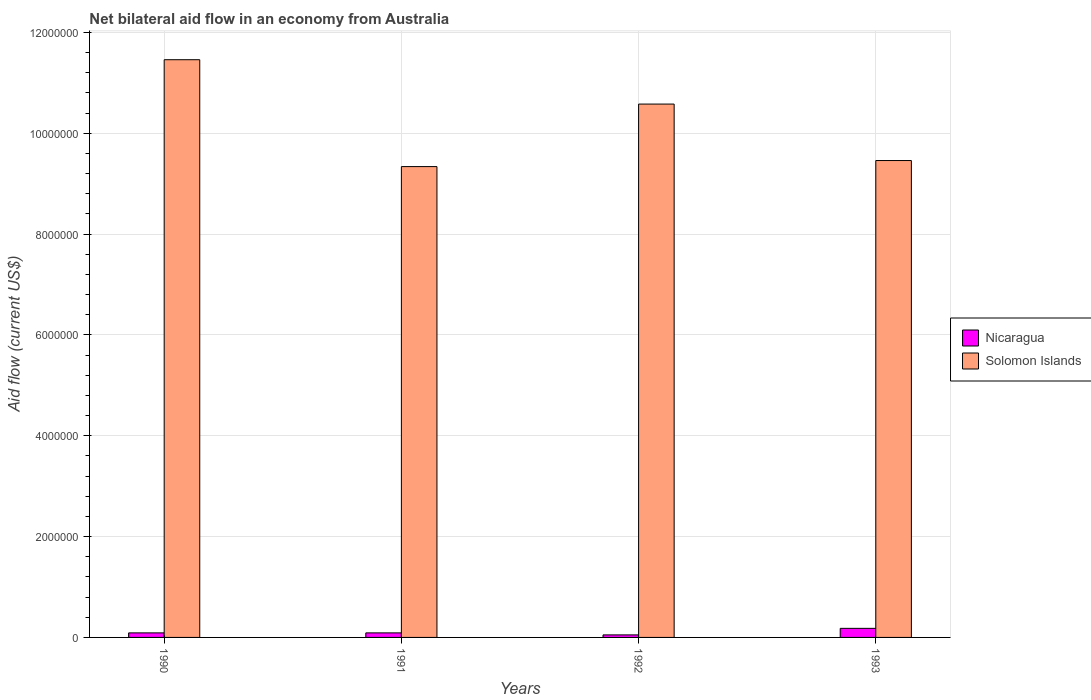How many bars are there on the 4th tick from the left?
Offer a very short reply. 2. What is the net bilateral aid flow in Nicaragua in 1992?
Ensure brevity in your answer.  5.00e+04. Across all years, what is the maximum net bilateral aid flow in Solomon Islands?
Offer a terse response. 1.15e+07. Across all years, what is the minimum net bilateral aid flow in Solomon Islands?
Offer a terse response. 9.34e+06. What is the total net bilateral aid flow in Solomon Islands in the graph?
Make the answer very short. 4.08e+07. What is the difference between the net bilateral aid flow in Solomon Islands in 1990 and that in 1993?
Offer a terse response. 2.00e+06. What is the difference between the net bilateral aid flow in Solomon Islands in 1992 and the net bilateral aid flow in Nicaragua in 1993?
Make the answer very short. 1.04e+07. What is the average net bilateral aid flow in Solomon Islands per year?
Offer a very short reply. 1.02e+07. In the year 1993, what is the difference between the net bilateral aid flow in Nicaragua and net bilateral aid flow in Solomon Islands?
Ensure brevity in your answer.  -9.28e+06. What is the ratio of the net bilateral aid flow in Nicaragua in 1990 to that in 1991?
Provide a short and direct response. 1. What is the difference between the highest and the second highest net bilateral aid flow in Nicaragua?
Offer a terse response. 9.00e+04. What does the 1st bar from the left in 1991 represents?
Give a very brief answer. Nicaragua. What does the 1st bar from the right in 1991 represents?
Give a very brief answer. Solomon Islands. How many bars are there?
Your answer should be very brief. 8. How many years are there in the graph?
Make the answer very short. 4. Does the graph contain any zero values?
Keep it short and to the point. No. Where does the legend appear in the graph?
Provide a succinct answer. Center right. How are the legend labels stacked?
Offer a terse response. Vertical. What is the title of the graph?
Your answer should be very brief. Net bilateral aid flow in an economy from Australia. What is the label or title of the X-axis?
Your response must be concise. Years. What is the Aid flow (current US$) of Solomon Islands in 1990?
Your answer should be very brief. 1.15e+07. What is the Aid flow (current US$) in Solomon Islands in 1991?
Keep it short and to the point. 9.34e+06. What is the Aid flow (current US$) of Nicaragua in 1992?
Your answer should be very brief. 5.00e+04. What is the Aid flow (current US$) of Solomon Islands in 1992?
Keep it short and to the point. 1.06e+07. What is the Aid flow (current US$) in Solomon Islands in 1993?
Provide a succinct answer. 9.46e+06. Across all years, what is the maximum Aid flow (current US$) in Solomon Islands?
Offer a very short reply. 1.15e+07. Across all years, what is the minimum Aid flow (current US$) of Nicaragua?
Keep it short and to the point. 5.00e+04. Across all years, what is the minimum Aid flow (current US$) of Solomon Islands?
Keep it short and to the point. 9.34e+06. What is the total Aid flow (current US$) in Nicaragua in the graph?
Keep it short and to the point. 4.10e+05. What is the total Aid flow (current US$) in Solomon Islands in the graph?
Ensure brevity in your answer.  4.08e+07. What is the difference between the Aid flow (current US$) of Nicaragua in 1990 and that in 1991?
Offer a terse response. 0. What is the difference between the Aid flow (current US$) of Solomon Islands in 1990 and that in 1991?
Provide a succinct answer. 2.12e+06. What is the difference between the Aid flow (current US$) in Solomon Islands in 1990 and that in 1992?
Your response must be concise. 8.80e+05. What is the difference between the Aid flow (current US$) in Solomon Islands in 1991 and that in 1992?
Give a very brief answer. -1.24e+06. What is the difference between the Aid flow (current US$) in Solomon Islands in 1991 and that in 1993?
Provide a short and direct response. -1.20e+05. What is the difference between the Aid flow (current US$) of Nicaragua in 1992 and that in 1993?
Offer a very short reply. -1.30e+05. What is the difference between the Aid flow (current US$) in Solomon Islands in 1992 and that in 1993?
Keep it short and to the point. 1.12e+06. What is the difference between the Aid flow (current US$) in Nicaragua in 1990 and the Aid flow (current US$) in Solomon Islands in 1991?
Your answer should be compact. -9.25e+06. What is the difference between the Aid flow (current US$) in Nicaragua in 1990 and the Aid flow (current US$) in Solomon Islands in 1992?
Give a very brief answer. -1.05e+07. What is the difference between the Aid flow (current US$) of Nicaragua in 1990 and the Aid flow (current US$) of Solomon Islands in 1993?
Ensure brevity in your answer.  -9.37e+06. What is the difference between the Aid flow (current US$) of Nicaragua in 1991 and the Aid flow (current US$) of Solomon Islands in 1992?
Your response must be concise. -1.05e+07. What is the difference between the Aid flow (current US$) in Nicaragua in 1991 and the Aid flow (current US$) in Solomon Islands in 1993?
Ensure brevity in your answer.  -9.37e+06. What is the difference between the Aid flow (current US$) in Nicaragua in 1992 and the Aid flow (current US$) in Solomon Islands in 1993?
Give a very brief answer. -9.41e+06. What is the average Aid flow (current US$) in Nicaragua per year?
Your answer should be compact. 1.02e+05. What is the average Aid flow (current US$) of Solomon Islands per year?
Your answer should be very brief. 1.02e+07. In the year 1990, what is the difference between the Aid flow (current US$) in Nicaragua and Aid flow (current US$) in Solomon Islands?
Provide a short and direct response. -1.14e+07. In the year 1991, what is the difference between the Aid flow (current US$) in Nicaragua and Aid flow (current US$) in Solomon Islands?
Ensure brevity in your answer.  -9.25e+06. In the year 1992, what is the difference between the Aid flow (current US$) in Nicaragua and Aid flow (current US$) in Solomon Islands?
Your answer should be very brief. -1.05e+07. In the year 1993, what is the difference between the Aid flow (current US$) in Nicaragua and Aid flow (current US$) in Solomon Islands?
Offer a very short reply. -9.28e+06. What is the ratio of the Aid flow (current US$) in Solomon Islands in 1990 to that in 1991?
Your answer should be very brief. 1.23. What is the ratio of the Aid flow (current US$) in Nicaragua in 1990 to that in 1992?
Give a very brief answer. 1.8. What is the ratio of the Aid flow (current US$) of Solomon Islands in 1990 to that in 1992?
Keep it short and to the point. 1.08. What is the ratio of the Aid flow (current US$) of Nicaragua in 1990 to that in 1993?
Offer a very short reply. 0.5. What is the ratio of the Aid flow (current US$) in Solomon Islands in 1990 to that in 1993?
Make the answer very short. 1.21. What is the ratio of the Aid flow (current US$) of Nicaragua in 1991 to that in 1992?
Ensure brevity in your answer.  1.8. What is the ratio of the Aid flow (current US$) of Solomon Islands in 1991 to that in 1992?
Provide a short and direct response. 0.88. What is the ratio of the Aid flow (current US$) in Solomon Islands in 1991 to that in 1993?
Make the answer very short. 0.99. What is the ratio of the Aid flow (current US$) of Nicaragua in 1992 to that in 1993?
Ensure brevity in your answer.  0.28. What is the ratio of the Aid flow (current US$) in Solomon Islands in 1992 to that in 1993?
Offer a terse response. 1.12. What is the difference between the highest and the second highest Aid flow (current US$) of Solomon Islands?
Your response must be concise. 8.80e+05. What is the difference between the highest and the lowest Aid flow (current US$) in Nicaragua?
Provide a succinct answer. 1.30e+05. What is the difference between the highest and the lowest Aid flow (current US$) of Solomon Islands?
Offer a terse response. 2.12e+06. 